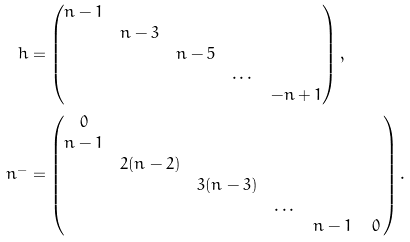<formula> <loc_0><loc_0><loc_500><loc_500>h & = \begin{pmatrix} n - 1 & & & & \\ & n - 3 & & & \\ & & n - 5 & & \\ & & & \dots & \\ & & & & - n + 1 \end{pmatrix} , \\ n ^ { - } & = \begin{pmatrix} 0 & & & & & \\ n - 1 & & & & & \\ & 2 ( n - 2 ) & & & & \\ & & 3 ( n - 3 ) & & & \\ & & & \dots & & \\ & & & & n - 1 & \, 0 \, \end{pmatrix} .</formula> 